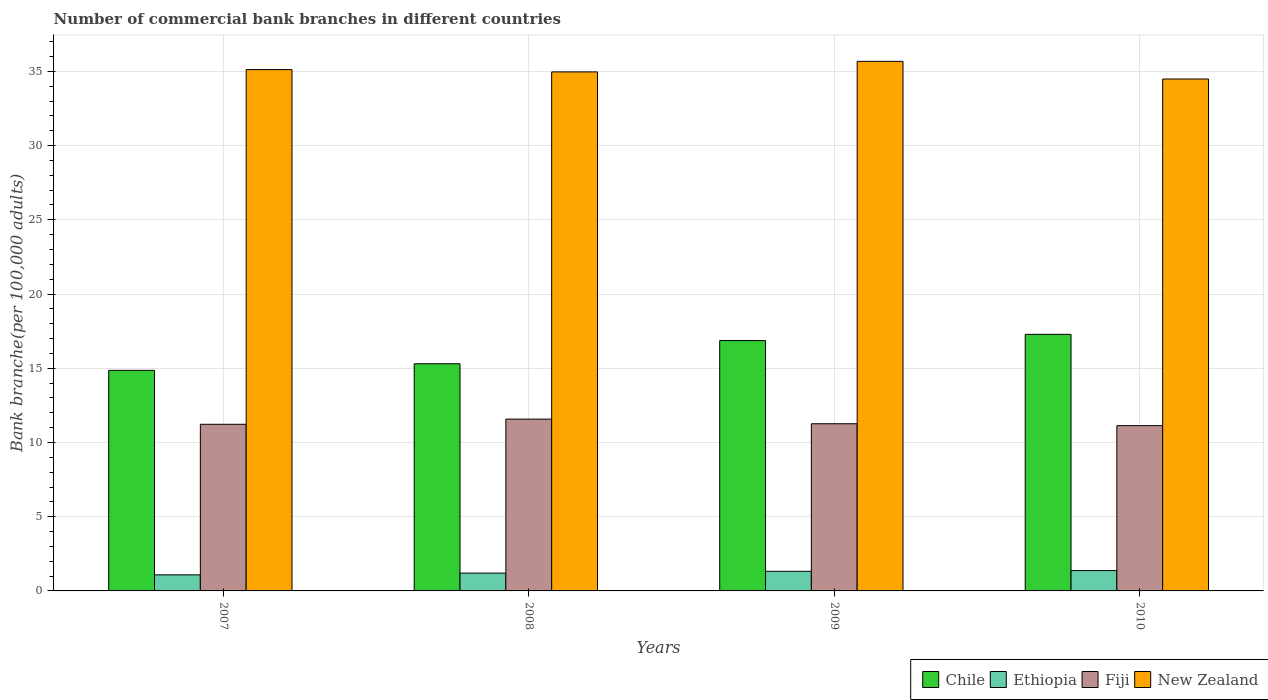How many groups of bars are there?
Your response must be concise. 4. Are the number of bars on each tick of the X-axis equal?
Make the answer very short. Yes. How many bars are there on the 1st tick from the left?
Provide a short and direct response. 4. What is the number of commercial bank branches in New Zealand in 2008?
Your response must be concise. 34.97. Across all years, what is the maximum number of commercial bank branches in Ethiopia?
Keep it short and to the point. 1.37. Across all years, what is the minimum number of commercial bank branches in New Zealand?
Provide a succinct answer. 34.49. In which year was the number of commercial bank branches in Fiji minimum?
Your answer should be compact. 2010. What is the total number of commercial bank branches in Ethiopia in the graph?
Provide a short and direct response. 4.97. What is the difference between the number of commercial bank branches in New Zealand in 2007 and that in 2008?
Offer a very short reply. 0.16. What is the difference between the number of commercial bank branches in New Zealand in 2010 and the number of commercial bank branches in Fiji in 2009?
Ensure brevity in your answer.  23.22. What is the average number of commercial bank branches in New Zealand per year?
Provide a succinct answer. 35.06. In the year 2008, what is the difference between the number of commercial bank branches in Chile and number of commercial bank branches in Fiji?
Keep it short and to the point. 3.73. What is the ratio of the number of commercial bank branches in New Zealand in 2007 to that in 2009?
Provide a succinct answer. 0.98. Is the number of commercial bank branches in Chile in 2007 less than that in 2010?
Offer a very short reply. Yes. What is the difference between the highest and the second highest number of commercial bank branches in New Zealand?
Your response must be concise. 0.55. What is the difference between the highest and the lowest number of commercial bank branches in Chile?
Give a very brief answer. 2.42. Is the sum of the number of commercial bank branches in Chile in 2009 and 2010 greater than the maximum number of commercial bank branches in New Zealand across all years?
Provide a short and direct response. No. What does the 4th bar from the right in 2010 represents?
Offer a very short reply. Chile. Are all the bars in the graph horizontal?
Offer a terse response. No. How many years are there in the graph?
Make the answer very short. 4. Does the graph contain any zero values?
Provide a succinct answer. No. Does the graph contain grids?
Your answer should be compact. Yes. Where does the legend appear in the graph?
Provide a short and direct response. Bottom right. How are the legend labels stacked?
Your answer should be very brief. Horizontal. What is the title of the graph?
Give a very brief answer. Number of commercial bank branches in different countries. What is the label or title of the X-axis?
Your answer should be very brief. Years. What is the label or title of the Y-axis?
Your answer should be very brief. Bank branche(per 100,0 adults). What is the Bank branche(per 100,000 adults) of Chile in 2007?
Offer a terse response. 14.86. What is the Bank branche(per 100,000 adults) of Ethiopia in 2007?
Keep it short and to the point. 1.08. What is the Bank branche(per 100,000 adults) of Fiji in 2007?
Ensure brevity in your answer.  11.23. What is the Bank branche(per 100,000 adults) in New Zealand in 2007?
Provide a succinct answer. 35.12. What is the Bank branche(per 100,000 adults) in Chile in 2008?
Ensure brevity in your answer.  15.3. What is the Bank branche(per 100,000 adults) in Ethiopia in 2008?
Give a very brief answer. 1.2. What is the Bank branche(per 100,000 adults) in Fiji in 2008?
Give a very brief answer. 11.57. What is the Bank branche(per 100,000 adults) of New Zealand in 2008?
Make the answer very short. 34.97. What is the Bank branche(per 100,000 adults) of Chile in 2009?
Ensure brevity in your answer.  16.87. What is the Bank branche(per 100,000 adults) in Ethiopia in 2009?
Offer a very short reply. 1.32. What is the Bank branche(per 100,000 adults) of Fiji in 2009?
Offer a very short reply. 11.26. What is the Bank branche(per 100,000 adults) of New Zealand in 2009?
Give a very brief answer. 35.68. What is the Bank branche(per 100,000 adults) of Chile in 2010?
Provide a succinct answer. 17.28. What is the Bank branche(per 100,000 adults) in Ethiopia in 2010?
Your answer should be very brief. 1.37. What is the Bank branche(per 100,000 adults) in Fiji in 2010?
Make the answer very short. 11.14. What is the Bank branche(per 100,000 adults) of New Zealand in 2010?
Your answer should be very brief. 34.49. Across all years, what is the maximum Bank branche(per 100,000 adults) in Chile?
Provide a succinct answer. 17.28. Across all years, what is the maximum Bank branche(per 100,000 adults) of Ethiopia?
Your response must be concise. 1.37. Across all years, what is the maximum Bank branche(per 100,000 adults) of Fiji?
Make the answer very short. 11.57. Across all years, what is the maximum Bank branche(per 100,000 adults) in New Zealand?
Offer a very short reply. 35.68. Across all years, what is the minimum Bank branche(per 100,000 adults) in Chile?
Give a very brief answer. 14.86. Across all years, what is the minimum Bank branche(per 100,000 adults) in Ethiopia?
Provide a succinct answer. 1.08. Across all years, what is the minimum Bank branche(per 100,000 adults) in Fiji?
Offer a terse response. 11.14. Across all years, what is the minimum Bank branche(per 100,000 adults) of New Zealand?
Ensure brevity in your answer.  34.49. What is the total Bank branche(per 100,000 adults) of Chile in the graph?
Your answer should be very brief. 64.31. What is the total Bank branche(per 100,000 adults) in Ethiopia in the graph?
Offer a terse response. 4.97. What is the total Bank branche(per 100,000 adults) in Fiji in the graph?
Keep it short and to the point. 45.2. What is the total Bank branche(per 100,000 adults) in New Zealand in the graph?
Your response must be concise. 140.25. What is the difference between the Bank branche(per 100,000 adults) of Chile in 2007 and that in 2008?
Keep it short and to the point. -0.44. What is the difference between the Bank branche(per 100,000 adults) of Ethiopia in 2007 and that in 2008?
Offer a very short reply. -0.12. What is the difference between the Bank branche(per 100,000 adults) in Fiji in 2007 and that in 2008?
Make the answer very short. -0.35. What is the difference between the Bank branche(per 100,000 adults) of New Zealand in 2007 and that in 2008?
Your response must be concise. 0.16. What is the difference between the Bank branche(per 100,000 adults) in Chile in 2007 and that in 2009?
Your response must be concise. -2.01. What is the difference between the Bank branche(per 100,000 adults) in Ethiopia in 2007 and that in 2009?
Provide a short and direct response. -0.24. What is the difference between the Bank branche(per 100,000 adults) of Fiji in 2007 and that in 2009?
Your response must be concise. -0.04. What is the difference between the Bank branche(per 100,000 adults) in New Zealand in 2007 and that in 2009?
Make the answer very short. -0.55. What is the difference between the Bank branche(per 100,000 adults) of Chile in 2007 and that in 2010?
Offer a very short reply. -2.42. What is the difference between the Bank branche(per 100,000 adults) in Ethiopia in 2007 and that in 2010?
Your response must be concise. -0.29. What is the difference between the Bank branche(per 100,000 adults) in Fiji in 2007 and that in 2010?
Make the answer very short. 0.09. What is the difference between the Bank branche(per 100,000 adults) in New Zealand in 2007 and that in 2010?
Give a very brief answer. 0.63. What is the difference between the Bank branche(per 100,000 adults) in Chile in 2008 and that in 2009?
Offer a very short reply. -1.56. What is the difference between the Bank branche(per 100,000 adults) in Ethiopia in 2008 and that in 2009?
Make the answer very short. -0.12. What is the difference between the Bank branche(per 100,000 adults) in Fiji in 2008 and that in 2009?
Provide a succinct answer. 0.31. What is the difference between the Bank branche(per 100,000 adults) in New Zealand in 2008 and that in 2009?
Your answer should be very brief. -0.71. What is the difference between the Bank branche(per 100,000 adults) of Chile in 2008 and that in 2010?
Keep it short and to the point. -1.98. What is the difference between the Bank branche(per 100,000 adults) in Ethiopia in 2008 and that in 2010?
Make the answer very short. -0.17. What is the difference between the Bank branche(per 100,000 adults) in Fiji in 2008 and that in 2010?
Ensure brevity in your answer.  0.44. What is the difference between the Bank branche(per 100,000 adults) in New Zealand in 2008 and that in 2010?
Ensure brevity in your answer.  0.48. What is the difference between the Bank branche(per 100,000 adults) in Chile in 2009 and that in 2010?
Your response must be concise. -0.42. What is the difference between the Bank branche(per 100,000 adults) of Ethiopia in 2009 and that in 2010?
Your answer should be compact. -0.05. What is the difference between the Bank branche(per 100,000 adults) of Fiji in 2009 and that in 2010?
Give a very brief answer. 0.13. What is the difference between the Bank branche(per 100,000 adults) in New Zealand in 2009 and that in 2010?
Make the answer very short. 1.19. What is the difference between the Bank branche(per 100,000 adults) of Chile in 2007 and the Bank branche(per 100,000 adults) of Ethiopia in 2008?
Give a very brief answer. 13.66. What is the difference between the Bank branche(per 100,000 adults) in Chile in 2007 and the Bank branche(per 100,000 adults) in Fiji in 2008?
Offer a very short reply. 3.29. What is the difference between the Bank branche(per 100,000 adults) of Chile in 2007 and the Bank branche(per 100,000 adults) of New Zealand in 2008?
Give a very brief answer. -20.11. What is the difference between the Bank branche(per 100,000 adults) in Ethiopia in 2007 and the Bank branche(per 100,000 adults) in Fiji in 2008?
Ensure brevity in your answer.  -10.49. What is the difference between the Bank branche(per 100,000 adults) of Ethiopia in 2007 and the Bank branche(per 100,000 adults) of New Zealand in 2008?
Ensure brevity in your answer.  -33.88. What is the difference between the Bank branche(per 100,000 adults) of Fiji in 2007 and the Bank branche(per 100,000 adults) of New Zealand in 2008?
Your response must be concise. -23.74. What is the difference between the Bank branche(per 100,000 adults) in Chile in 2007 and the Bank branche(per 100,000 adults) in Ethiopia in 2009?
Keep it short and to the point. 13.54. What is the difference between the Bank branche(per 100,000 adults) in Chile in 2007 and the Bank branche(per 100,000 adults) in Fiji in 2009?
Your answer should be very brief. 3.6. What is the difference between the Bank branche(per 100,000 adults) in Chile in 2007 and the Bank branche(per 100,000 adults) in New Zealand in 2009?
Ensure brevity in your answer.  -20.82. What is the difference between the Bank branche(per 100,000 adults) of Ethiopia in 2007 and the Bank branche(per 100,000 adults) of Fiji in 2009?
Provide a short and direct response. -10.18. What is the difference between the Bank branche(per 100,000 adults) in Ethiopia in 2007 and the Bank branche(per 100,000 adults) in New Zealand in 2009?
Make the answer very short. -34.59. What is the difference between the Bank branche(per 100,000 adults) in Fiji in 2007 and the Bank branche(per 100,000 adults) in New Zealand in 2009?
Your answer should be compact. -24.45. What is the difference between the Bank branche(per 100,000 adults) in Chile in 2007 and the Bank branche(per 100,000 adults) in Ethiopia in 2010?
Your answer should be compact. 13.49. What is the difference between the Bank branche(per 100,000 adults) in Chile in 2007 and the Bank branche(per 100,000 adults) in Fiji in 2010?
Your answer should be compact. 3.72. What is the difference between the Bank branche(per 100,000 adults) in Chile in 2007 and the Bank branche(per 100,000 adults) in New Zealand in 2010?
Offer a terse response. -19.63. What is the difference between the Bank branche(per 100,000 adults) in Ethiopia in 2007 and the Bank branche(per 100,000 adults) in Fiji in 2010?
Your response must be concise. -10.05. What is the difference between the Bank branche(per 100,000 adults) of Ethiopia in 2007 and the Bank branche(per 100,000 adults) of New Zealand in 2010?
Your response must be concise. -33.4. What is the difference between the Bank branche(per 100,000 adults) of Fiji in 2007 and the Bank branche(per 100,000 adults) of New Zealand in 2010?
Keep it short and to the point. -23.26. What is the difference between the Bank branche(per 100,000 adults) of Chile in 2008 and the Bank branche(per 100,000 adults) of Ethiopia in 2009?
Your response must be concise. 13.98. What is the difference between the Bank branche(per 100,000 adults) in Chile in 2008 and the Bank branche(per 100,000 adults) in Fiji in 2009?
Offer a terse response. 4.04. What is the difference between the Bank branche(per 100,000 adults) of Chile in 2008 and the Bank branche(per 100,000 adults) of New Zealand in 2009?
Ensure brevity in your answer.  -20.37. What is the difference between the Bank branche(per 100,000 adults) in Ethiopia in 2008 and the Bank branche(per 100,000 adults) in Fiji in 2009?
Keep it short and to the point. -10.06. What is the difference between the Bank branche(per 100,000 adults) of Ethiopia in 2008 and the Bank branche(per 100,000 adults) of New Zealand in 2009?
Ensure brevity in your answer.  -34.48. What is the difference between the Bank branche(per 100,000 adults) in Fiji in 2008 and the Bank branche(per 100,000 adults) in New Zealand in 2009?
Provide a succinct answer. -24.1. What is the difference between the Bank branche(per 100,000 adults) of Chile in 2008 and the Bank branche(per 100,000 adults) of Ethiopia in 2010?
Offer a terse response. 13.93. What is the difference between the Bank branche(per 100,000 adults) in Chile in 2008 and the Bank branche(per 100,000 adults) in Fiji in 2010?
Make the answer very short. 4.17. What is the difference between the Bank branche(per 100,000 adults) in Chile in 2008 and the Bank branche(per 100,000 adults) in New Zealand in 2010?
Provide a succinct answer. -19.18. What is the difference between the Bank branche(per 100,000 adults) in Ethiopia in 2008 and the Bank branche(per 100,000 adults) in Fiji in 2010?
Provide a short and direct response. -9.94. What is the difference between the Bank branche(per 100,000 adults) of Ethiopia in 2008 and the Bank branche(per 100,000 adults) of New Zealand in 2010?
Provide a succinct answer. -33.29. What is the difference between the Bank branche(per 100,000 adults) in Fiji in 2008 and the Bank branche(per 100,000 adults) in New Zealand in 2010?
Provide a succinct answer. -22.91. What is the difference between the Bank branche(per 100,000 adults) of Chile in 2009 and the Bank branche(per 100,000 adults) of Ethiopia in 2010?
Offer a terse response. 15.5. What is the difference between the Bank branche(per 100,000 adults) in Chile in 2009 and the Bank branche(per 100,000 adults) in Fiji in 2010?
Offer a very short reply. 5.73. What is the difference between the Bank branche(per 100,000 adults) in Chile in 2009 and the Bank branche(per 100,000 adults) in New Zealand in 2010?
Your answer should be compact. -17.62. What is the difference between the Bank branche(per 100,000 adults) in Ethiopia in 2009 and the Bank branche(per 100,000 adults) in Fiji in 2010?
Ensure brevity in your answer.  -9.81. What is the difference between the Bank branche(per 100,000 adults) of Ethiopia in 2009 and the Bank branche(per 100,000 adults) of New Zealand in 2010?
Offer a very short reply. -33.16. What is the difference between the Bank branche(per 100,000 adults) in Fiji in 2009 and the Bank branche(per 100,000 adults) in New Zealand in 2010?
Provide a succinct answer. -23.22. What is the average Bank branche(per 100,000 adults) in Chile per year?
Your answer should be compact. 16.08. What is the average Bank branche(per 100,000 adults) of Ethiopia per year?
Provide a short and direct response. 1.24. What is the average Bank branche(per 100,000 adults) of Fiji per year?
Provide a short and direct response. 11.3. What is the average Bank branche(per 100,000 adults) in New Zealand per year?
Make the answer very short. 35.06. In the year 2007, what is the difference between the Bank branche(per 100,000 adults) of Chile and Bank branche(per 100,000 adults) of Ethiopia?
Your answer should be compact. 13.78. In the year 2007, what is the difference between the Bank branche(per 100,000 adults) in Chile and Bank branche(per 100,000 adults) in Fiji?
Make the answer very short. 3.63. In the year 2007, what is the difference between the Bank branche(per 100,000 adults) in Chile and Bank branche(per 100,000 adults) in New Zealand?
Your answer should be compact. -20.26. In the year 2007, what is the difference between the Bank branche(per 100,000 adults) in Ethiopia and Bank branche(per 100,000 adults) in Fiji?
Give a very brief answer. -10.14. In the year 2007, what is the difference between the Bank branche(per 100,000 adults) in Ethiopia and Bank branche(per 100,000 adults) in New Zealand?
Provide a short and direct response. -34.04. In the year 2007, what is the difference between the Bank branche(per 100,000 adults) of Fiji and Bank branche(per 100,000 adults) of New Zealand?
Make the answer very short. -23.9. In the year 2008, what is the difference between the Bank branche(per 100,000 adults) in Chile and Bank branche(per 100,000 adults) in Ethiopia?
Offer a terse response. 14.1. In the year 2008, what is the difference between the Bank branche(per 100,000 adults) in Chile and Bank branche(per 100,000 adults) in Fiji?
Offer a terse response. 3.73. In the year 2008, what is the difference between the Bank branche(per 100,000 adults) in Chile and Bank branche(per 100,000 adults) in New Zealand?
Offer a terse response. -19.66. In the year 2008, what is the difference between the Bank branche(per 100,000 adults) in Ethiopia and Bank branche(per 100,000 adults) in Fiji?
Offer a very short reply. -10.37. In the year 2008, what is the difference between the Bank branche(per 100,000 adults) in Ethiopia and Bank branche(per 100,000 adults) in New Zealand?
Offer a very short reply. -33.77. In the year 2008, what is the difference between the Bank branche(per 100,000 adults) of Fiji and Bank branche(per 100,000 adults) of New Zealand?
Keep it short and to the point. -23.39. In the year 2009, what is the difference between the Bank branche(per 100,000 adults) in Chile and Bank branche(per 100,000 adults) in Ethiopia?
Provide a succinct answer. 15.54. In the year 2009, what is the difference between the Bank branche(per 100,000 adults) of Chile and Bank branche(per 100,000 adults) of Fiji?
Provide a short and direct response. 5.6. In the year 2009, what is the difference between the Bank branche(per 100,000 adults) of Chile and Bank branche(per 100,000 adults) of New Zealand?
Offer a very short reply. -18.81. In the year 2009, what is the difference between the Bank branche(per 100,000 adults) of Ethiopia and Bank branche(per 100,000 adults) of Fiji?
Keep it short and to the point. -9.94. In the year 2009, what is the difference between the Bank branche(per 100,000 adults) in Ethiopia and Bank branche(per 100,000 adults) in New Zealand?
Ensure brevity in your answer.  -34.35. In the year 2009, what is the difference between the Bank branche(per 100,000 adults) of Fiji and Bank branche(per 100,000 adults) of New Zealand?
Your answer should be compact. -24.41. In the year 2010, what is the difference between the Bank branche(per 100,000 adults) of Chile and Bank branche(per 100,000 adults) of Ethiopia?
Offer a terse response. 15.91. In the year 2010, what is the difference between the Bank branche(per 100,000 adults) of Chile and Bank branche(per 100,000 adults) of Fiji?
Make the answer very short. 6.15. In the year 2010, what is the difference between the Bank branche(per 100,000 adults) of Chile and Bank branche(per 100,000 adults) of New Zealand?
Ensure brevity in your answer.  -17.2. In the year 2010, what is the difference between the Bank branche(per 100,000 adults) in Ethiopia and Bank branche(per 100,000 adults) in Fiji?
Give a very brief answer. -9.77. In the year 2010, what is the difference between the Bank branche(per 100,000 adults) in Ethiopia and Bank branche(per 100,000 adults) in New Zealand?
Provide a short and direct response. -33.12. In the year 2010, what is the difference between the Bank branche(per 100,000 adults) in Fiji and Bank branche(per 100,000 adults) in New Zealand?
Your answer should be compact. -23.35. What is the ratio of the Bank branche(per 100,000 adults) of Chile in 2007 to that in 2008?
Keep it short and to the point. 0.97. What is the ratio of the Bank branche(per 100,000 adults) in Ethiopia in 2007 to that in 2008?
Your answer should be compact. 0.9. What is the ratio of the Bank branche(per 100,000 adults) of Fiji in 2007 to that in 2008?
Your response must be concise. 0.97. What is the ratio of the Bank branche(per 100,000 adults) in New Zealand in 2007 to that in 2008?
Offer a very short reply. 1. What is the ratio of the Bank branche(per 100,000 adults) in Chile in 2007 to that in 2009?
Offer a terse response. 0.88. What is the ratio of the Bank branche(per 100,000 adults) of Ethiopia in 2007 to that in 2009?
Your answer should be very brief. 0.82. What is the ratio of the Bank branche(per 100,000 adults) in Fiji in 2007 to that in 2009?
Your response must be concise. 1. What is the ratio of the Bank branche(per 100,000 adults) in New Zealand in 2007 to that in 2009?
Your response must be concise. 0.98. What is the ratio of the Bank branche(per 100,000 adults) in Chile in 2007 to that in 2010?
Give a very brief answer. 0.86. What is the ratio of the Bank branche(per 100,000 adults) in Ethiopia in 2007 to that in 2010?
Provide a succinct answer. 0.79. What is the ratio of the Bank branche(per 100,000 adults) of Fiji in 2007 to that in 2010?
Your answer should be compact. 1.01. What is the ratio of the Bank branche(per 100,000 adults) of New Zealand in 2007 to that in 2010?
Offer a terse response. 1.02. What is the ratio of the Bank branche(per 100,000 adults) of Chile in 2008 to that in 2009?
Offer a very short reply. 0.91. What is the ratio of the Bank branche(per 100,000 adults) of Ethiopia in 2008 to that in 2009?
Give a very brief answer. 0.91. What is the ratio of the Bank branche(per 100,000 adults) of Fiji in 2008 to that in 2009?
Keep it short and to the point. 1.03. What is the ratio of the Bank branche(per 100,000 adults) of New Zealand in 2008 to that in 2009?
Provide a succinct answer. 0.98. What is the ratio of the Bank branche(per 100,000 adults) in Chile in 2008 to that in 2010?
Make the answer very short. 0.89. What is the ratio of the Bank branche(per 100,000 adults) in Ethiopia in 2008 to that in 2010?
Your answer should be very brief. 0.88. What is the ratio of the Bank branche(per 100,000 adults) in Fiji in 2008 to that in 2010?
Give a very brief answer. 1.04. What is the ratio of the Bank branche(per 100,000 adults) of New Zealand in 2008 to that in 2010?
Your answer should be compact. 1.01. What is the ratio of the Bank branche(per 100,000 adults) in Chile in 2009 to that in 2010?
Ensure brevity in your answer.  0.98. What is the ratio of the Bank branche(per 100,000 adults) of Ethiopia in 2009 to that in 2010?
Offer a terse response. 0.97. What is the ratio of the Bank branche(per 100,000 adults) of Fiji in 2009 to that in 2010?
Your response must be concise. 1.01. What is the ratio of the Bank branche(per 100,000 adults) in New Zealand in 2009 to that in 2010?
Your answer should be very brief. 1.03. What is the difference between the highest and the second highest Bank branche(per 100,000 adults) in Chile?
Your answer should be compact. 0.42. What is the difference between the highest and the second highest Bank branche(per 100,000 adults) of Ethiopia?
Your answer should be very brief. 0.05. What is the difference between the highest and the second highest Bank branche(per 100,000 adults) in Fiji?
Keep it short and to the point. 0.31. What is the difference between the highest and the second highest Bank branche(per 100,000 adults) in New Zealand?
Give a very brief answer. 0.55. What is the difference between the highest and the lowest Bank branche(per 100,000 adults) of Chile?
Offer a terse response. 2.42. What is the difference between the highest and the lowest Bank branche(per 100,000 adults) in Ethiopia?
Your answer should be very brief. 0.29. What is the difference between the highest and the lowest Bank branche(per 100,000 adults) of Fiji?
Keep it short and to the point. 0.44. What is the difference between the highest and the lowest Bank branche(per 100,000 adults) of New Zealand?
Your response must be concise. 1.19. 